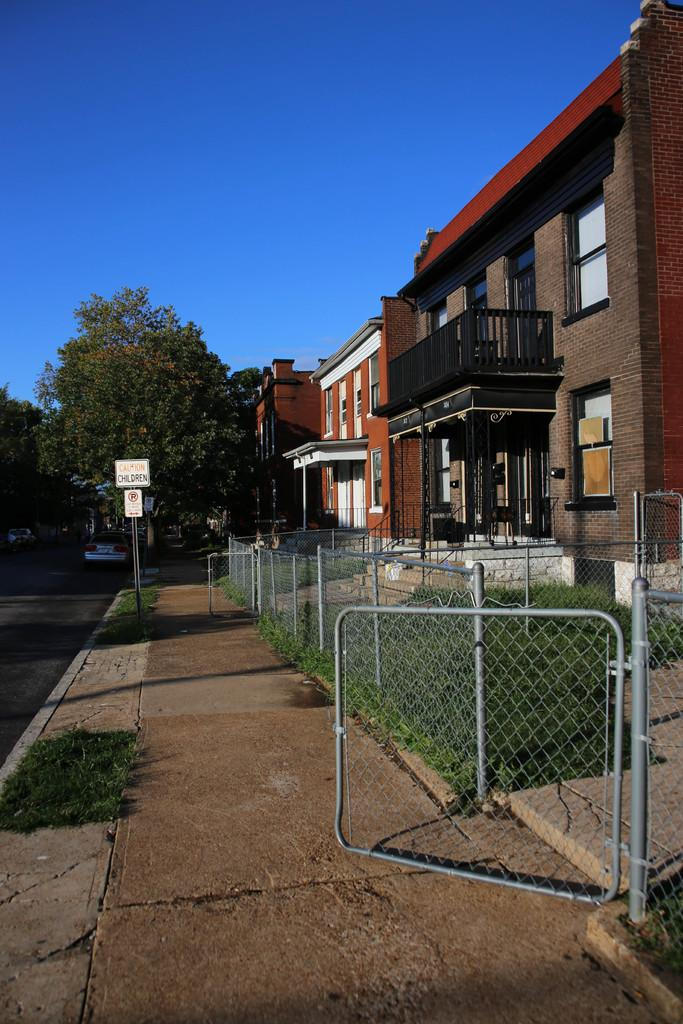What type of structures are visible in the image? There are buildings with windows in the image. What type of barrier can be seen in the image? There is a fence in the image. What type of vegetation is present in the image? There are trees and plants in the image. What object can be seen in the image that might be used for displaying information? There is a board in the image. What is visible in the background of the image? The sky is visible in the image. How many mice are climbing on the buildings in the image? There are no mice present in the image; it features buildings, a fence, trees, plants, a board, and the sky. What type of respect is shown by the trees in the image? There is no indication of respect in the image, as trees are inanimate objects and cannot display emotions or behaviors associated with respect. 